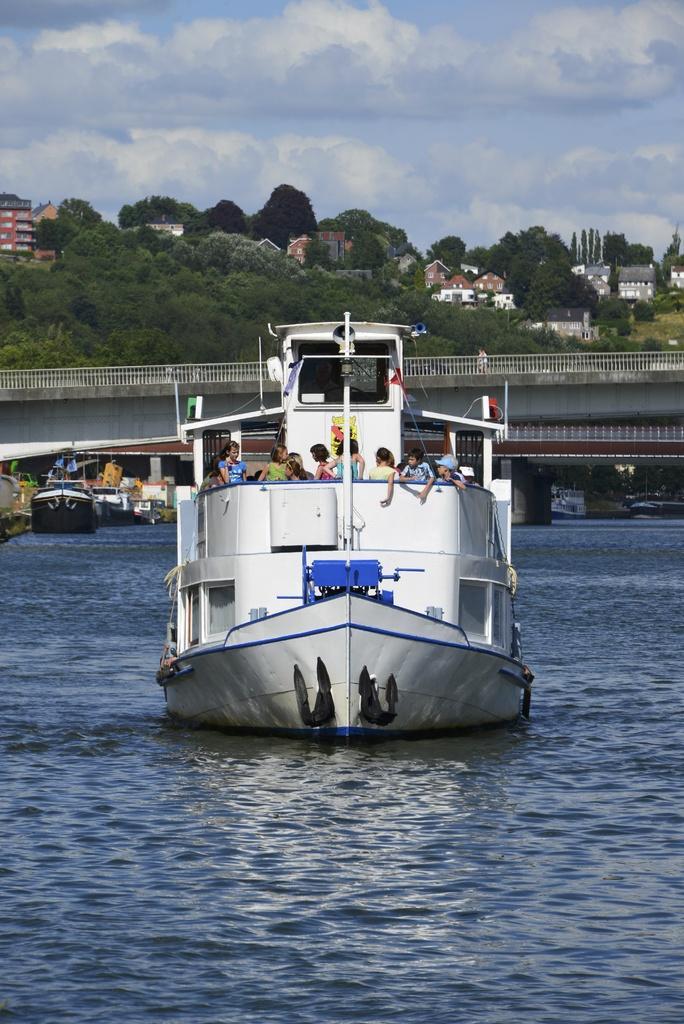Can you describe this image briefly? Here in this picture, in the middle we can see a boat present in the water and we can also see number of people present in the boat and behind that also we can see other number of boats present and in the middle we can see a bridge present and in the far we can see buildings present and we can see plants and trees covered all over there and we can see clouds in the sky. 